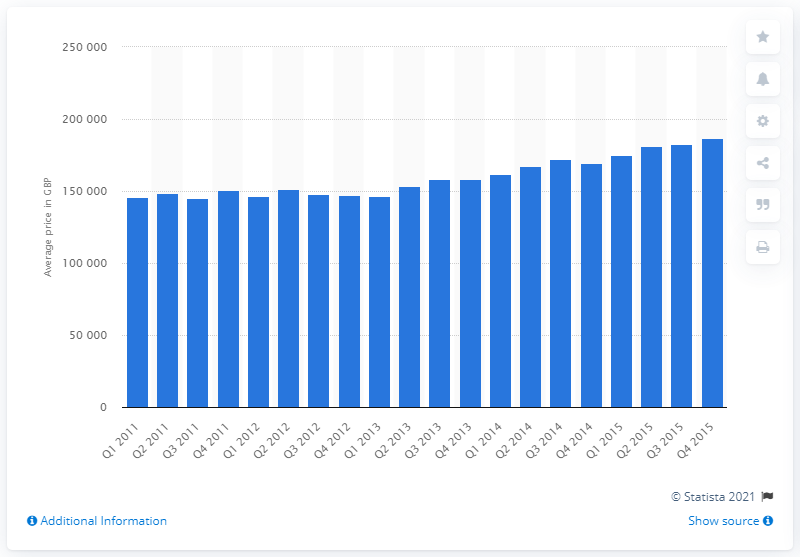Identify some key points in this picture. The average price of semi-detached houses built after 1960 was 182,521. 